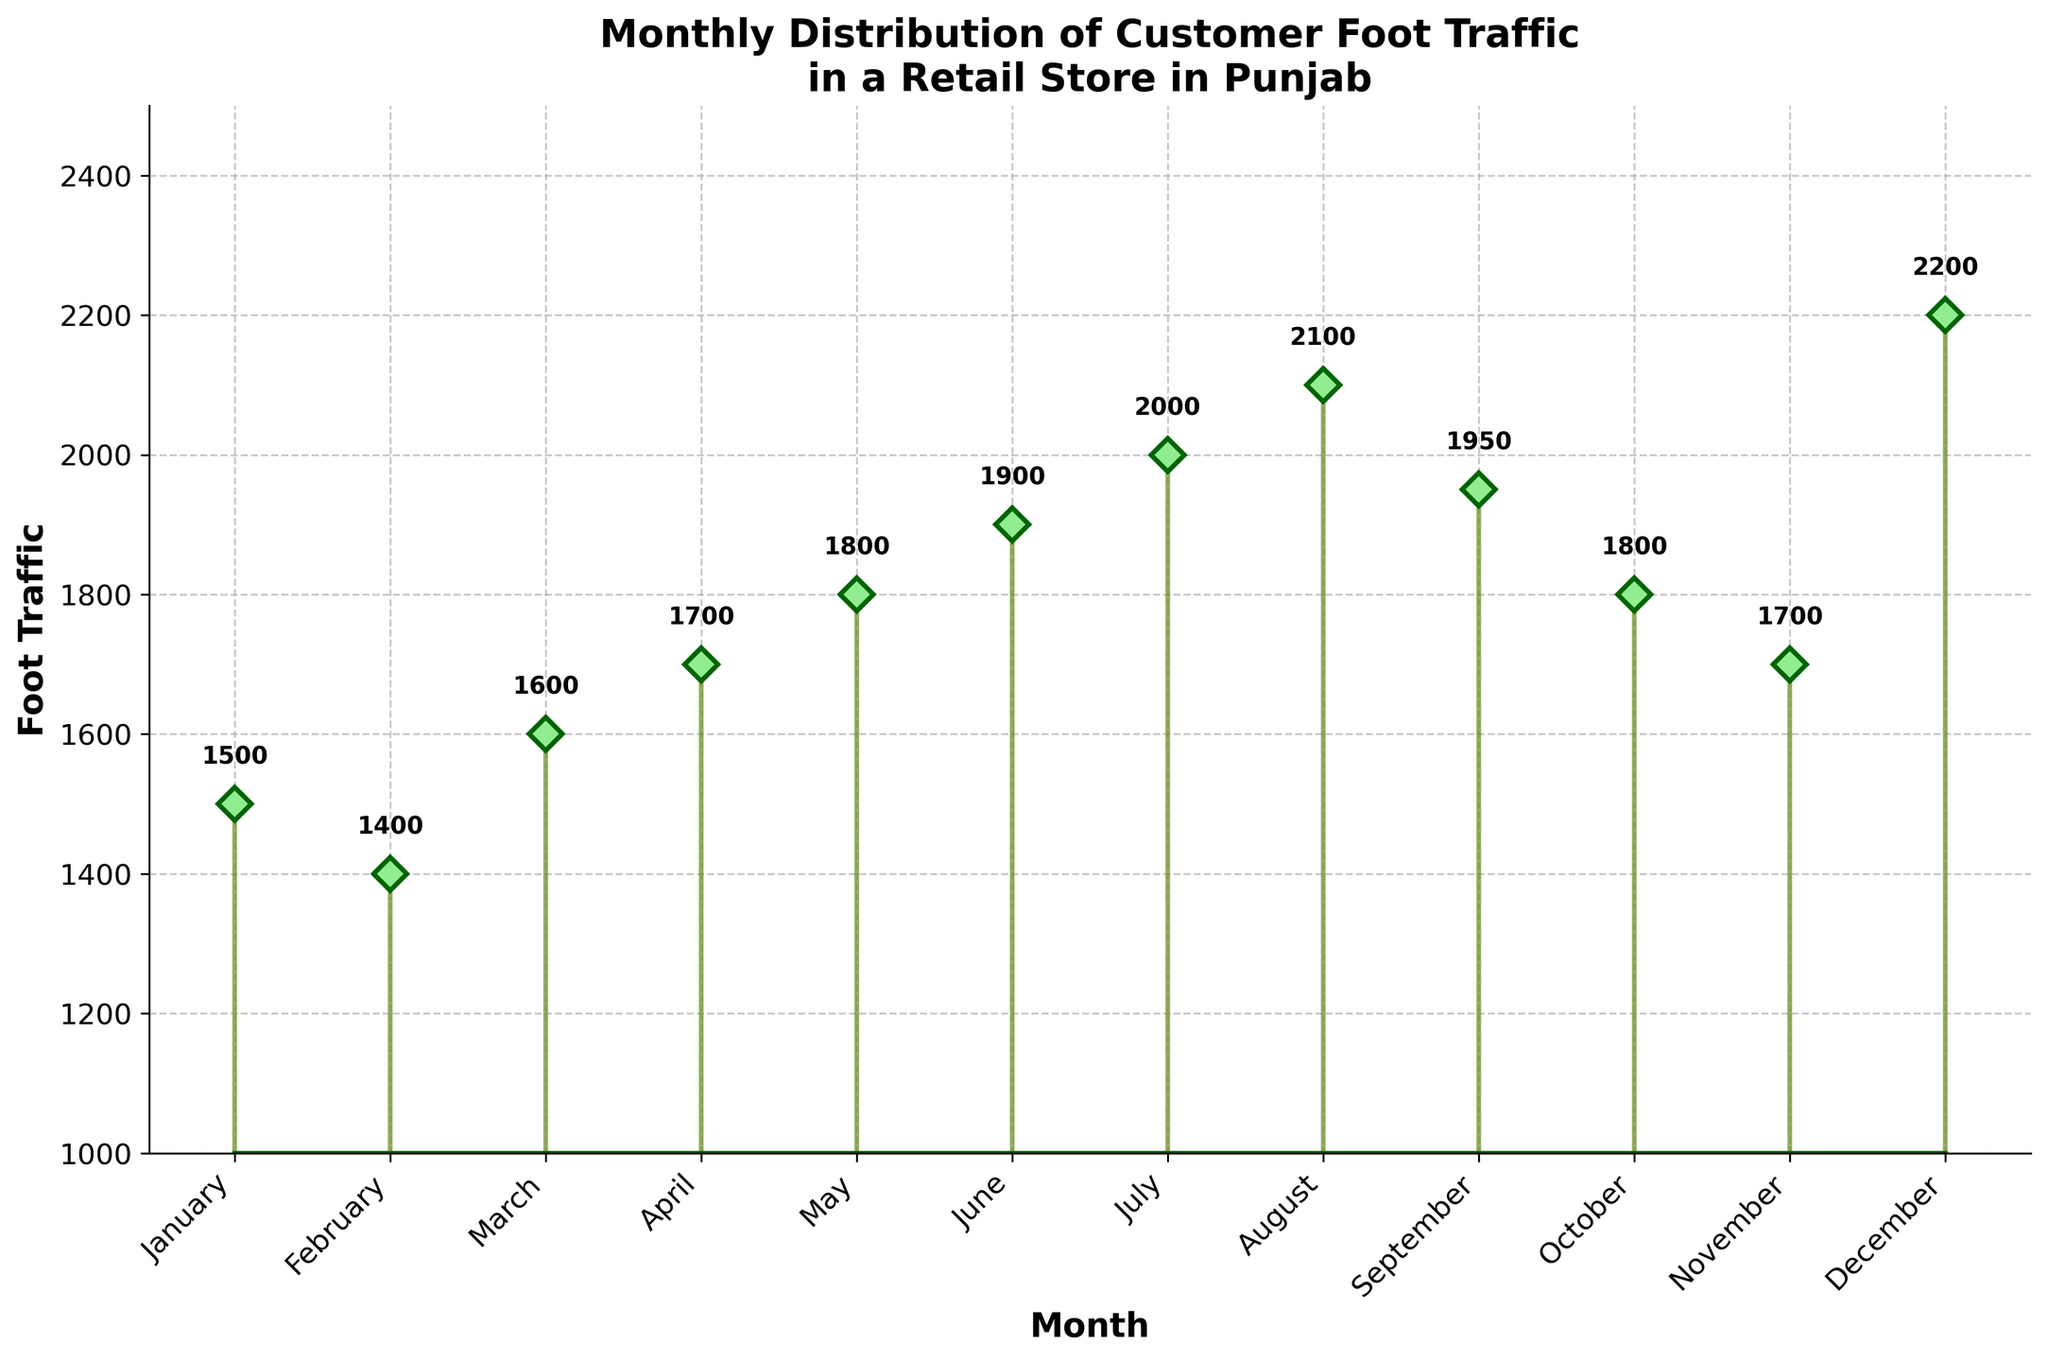What is the highest foot traffic recorded in any month? Looking at the stem plot, the highest point on the graph is at 2200 for December.
Answer: 2200 What is the foot traffic in July? Find the data point labeled "July" on the x-axis and read its corresponding y-axis value, which is 2000.
Answer: 2000 Which month has the lowest foot traffic? Identify the month with the smallest value on the y-axis. From the plot, it is February with 1400.
Answer: February What is the difference in foot traffic between June and January? June has a foot traffic of 1900, and January has 1500. Subtract 1500 from 1900 to find the difference.
Answer: 400 During which month does the foot traffic first exceed 2000? Scan the plot for the first instance where the y-axis value exceeds 2000. This occurs in August with a foot traffic of 2100.
Answer: August What is the average foot traffic for the first six months of the year? Sum the foot traffic from January to June: 1500 + 1400 + 1600 + 1700 + 1800 + 1900 = 9900. Divide by 6 to find the average: 9900/6.
Answer: 1650 Does May have more foot traffic than October? Compare the values for May (1800) and October (1800). They are equal.
Answer: No, they are equal How many months have a foot traffic greater than 1800? Identify and count months with y-axis values greater than 1800 (June, July, August, September, December). There are 5 such months.
Answer: 5 What is the total foot traffic for the months of March, April, and May? Add up the values for these months: 1600 (March) + 1700 (April) + 1800 (May) = 5100.
Answer: 5100 Which month exhibits a foot traffic trend reversal (an increase following a decrease or vice versa)? Look for a month where the foot traffic trend changes direction. November (1700) follows a decrease from October (1800) before December's increase (2200).
Answer: November 